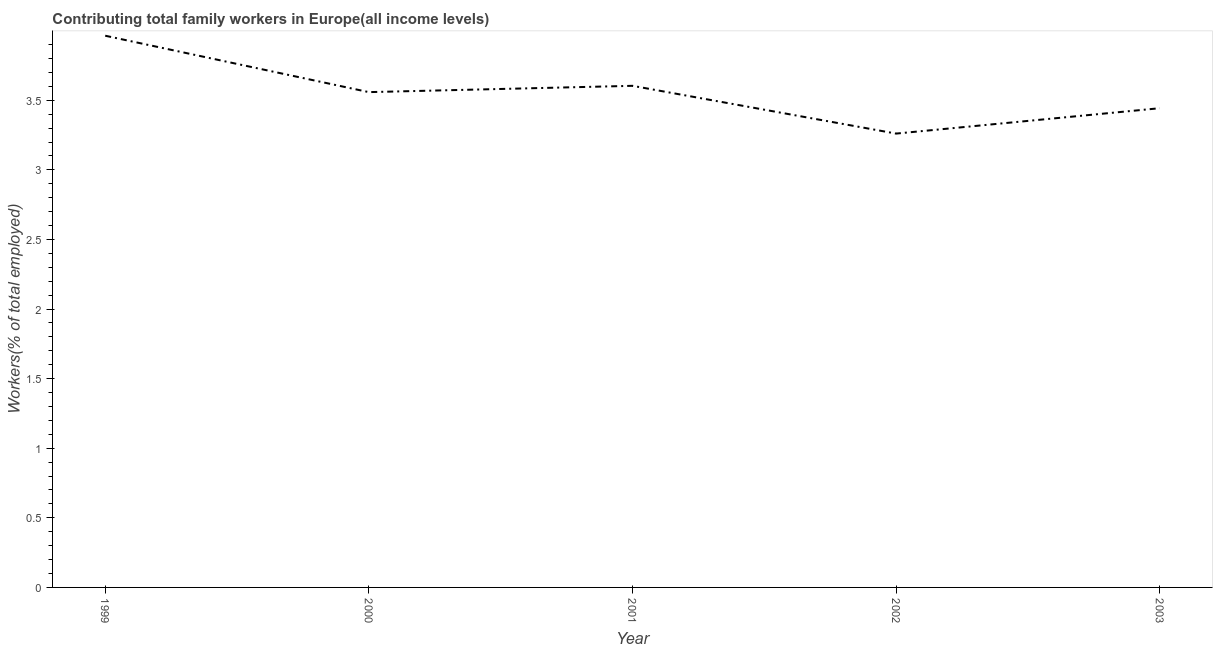What is the contributing family workers in 2003?
Your answer should be very brief. 3.44. Across all years, what is the maximum contributing family workers?
Offer a very short reply. 3.96. Across all years, what is the minimum contributing family workers?
Offer a very short reply. 3.26. What is the sum of the contributing family workers?
Your answer should be very brief. 17.83. What is the difference between the contributing family workers in 2000 and 2001?
Your response must be concise. -0.05. What is the average contributing family workers per year?
Keep it short and to the point. 3.57. What is the median contributing family workers?
Keep it short and to the point. 3.56. What is the ratio of the contributing family workers in 1999 to that in 2000?
Your answer should be compact. 1.11. Is the difference between the contributing family workers in 1999 and 2000 greater than the difference between any two years?
Offer a very short reply. No. What is the difference between the highest and the second highest contributing family workers?
Your answer should be compact. 0.36. What is the difference between the highest and the lowest contributing family workers?
Offer a terse response. 0.7. In how many years, is the contributing family workers greater than the average contributing family workers taken over all years?
Keep it short and to the point. 2. How many lines are there?
Keep it short and to the point. 1. How many years are there in the graph?
Make the answer very short. 5. What is the difference between two consecutive major ticks on the Y-axis?
Provide a short and direct response. 0.5. What is the title of the graph?
Make the answer very short. Contributing total family workers in Europe(all income levels). What is the label or title of the X-axis?
Your response must be concise. Year. What is the label or title of the Y-axis?
Your answer should be very brief. Workers(% of total employed). What is the Workers(% of total employed) of 1999?
Offer a terse response. 3.96. What is the Workers(% of total employed) in 2000?
Ensure brevity in your answer.  3.56. What is the Workers(% of total employed) in 2001?
Make the answer very short. 3.6. What is the Workers(% of total employed) in 2002?
Give a very brief answer. 3.26. What is the Workers(% of total employed) in 2003?
Keep it short and to the point. 3.44. What is the difference between the Workers(% of total employed) in 1999 and 2000?
Provide a succinct answer. 0.41. What is the difference between the Workers(% of total employed) in 1999 and 2001?
Make the answer very short. 0.36. What is the difference between the Workers(% of total employed) in 1999 and 2002?
Offer a terse response. 0.7. What is the difference between the Workers(% of total employed) in 1999 and 2003?
Your answer should be compact. 0.52. What is the difference between the Workers(% of total employed) in 2000 and 2001?
Offer a terse response. -0.05. What is the difference between the Workers(% of total employed) in 2000 and 2002?
Provide a succinct answer. 0.3. What is the difference between the Workers(% of total employed) in 2000 and 2003?
Your answer should be very brief. 0.12. What is the difference between the Workers(% of total employed) in 2001 and 2002?
Provide a short and direct response. 0.34. What is the difference between the Workers(% of total employed) in 2001 and 2003?
Your response must be concise. 0.16. What is the difference between the Workers(% of total employed) in 2002 and 2003?
Ensure brevity in your answer.  -0.18. What is the ratio of the Workers(% of total employed) in 1999 to that in 2000?
Give a very brief answer. 1.11. What is the ratio of the Workers(% of total employed) in 1999 to that in 2001?
Make the answer very short. 1.1. What is the ratio of the Workers(% of total employed) in 1999 to that in 2002?
Keep it short and to the point. 1.22. What is the ratio of the Workers(% of total employed) in 1999 to that in 2003?
Your answer should be very brief. 1.15. What is the ratio of the Workers(% of total employed) in 2000 to that in 2001?
Offer a very short reply. 0.99. What is the ratio of the Workers(% of total employed) in 2000 to that in 2002?
Offer a very short reply. 1.09. What is the ratio of the Workers(% of total employed) in 2000 to that in 2003?
Provide a succinct answer. 1.03. What is the ratio of the Workers(% of total employed) in 2001 to that in 2002?
Give a very brief answer. 1.1. What is the ratio of the Workers(% of total employed) in 2001 to that in 2003?
Provide a succinct answer. 1.05. What is the ratio of the Workers(% of total employed) in 2002 to that in 2003?
Offer a terse response. 0.95. 